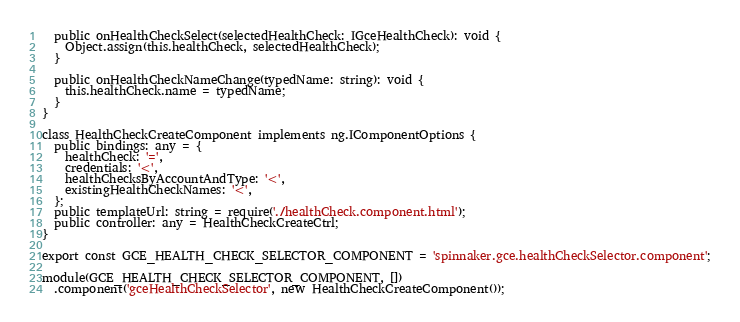<code> <loc_0><loc_0><loc_500><loc_500><_TypeScript_>
  public onHealthCheckSelect(selectedHealthCheck: IGceHealthCheck): void {
    Object.assign(this.healthCheck, selectedHealthCheck);
  }

  public onHealthCheckNameChange(typedName: string): void {
    this.healthCheck.name = typedName;
  }
}

class HealthCheckCreateComponent implements ng.IComponentOptions {
  public bindings: any = {
    healthCheck: '=',
    credentials: '<',
    healthChecksByAccountAndType: '<',
    existingHealthCheckNames: '<',
  };
  public templateUrl: string = require('./healthCheck.component.html');
  public controller: any = HealthCheckCreateCtrl;
}

export const GCE_HEALTH_CHECK_SELECTOR_COMPONENT = 'spinnaker.gce.healthCheckSelector.component';

module(GCE_HEALTH_CHECK_SELECTOR_COMPONENT, [])
  .component('gceHealthCheckSelector', new HealthCheckCreateComponent());

</code> 